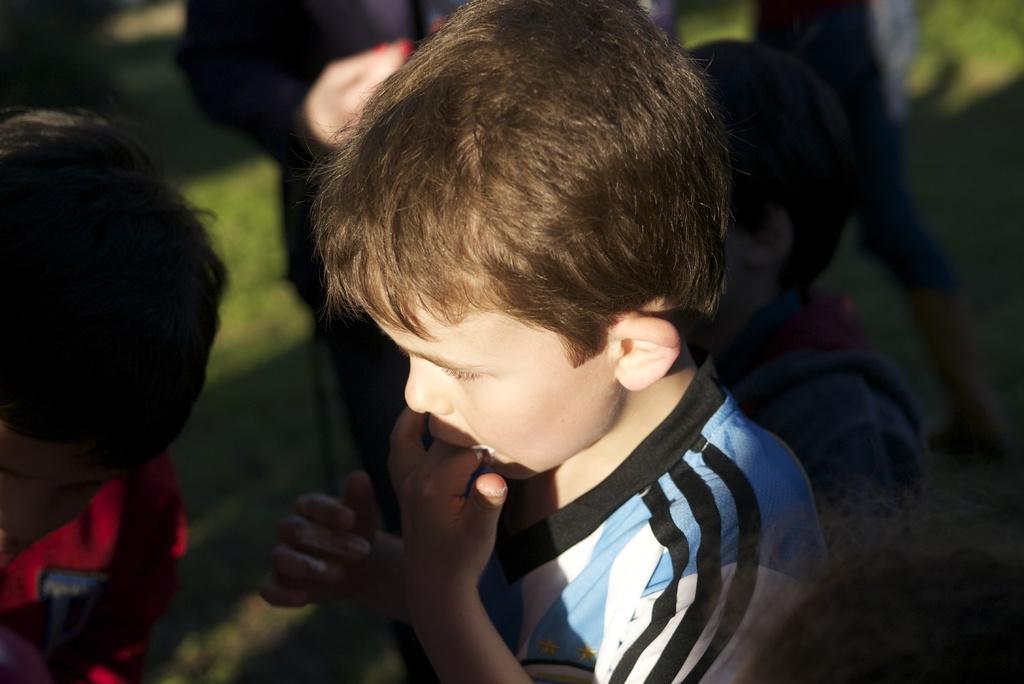Can you describe this image briefly? In this image there is a boy. He is putting his fingers in his mouth. There are few people around him. There is grass on the ground. 